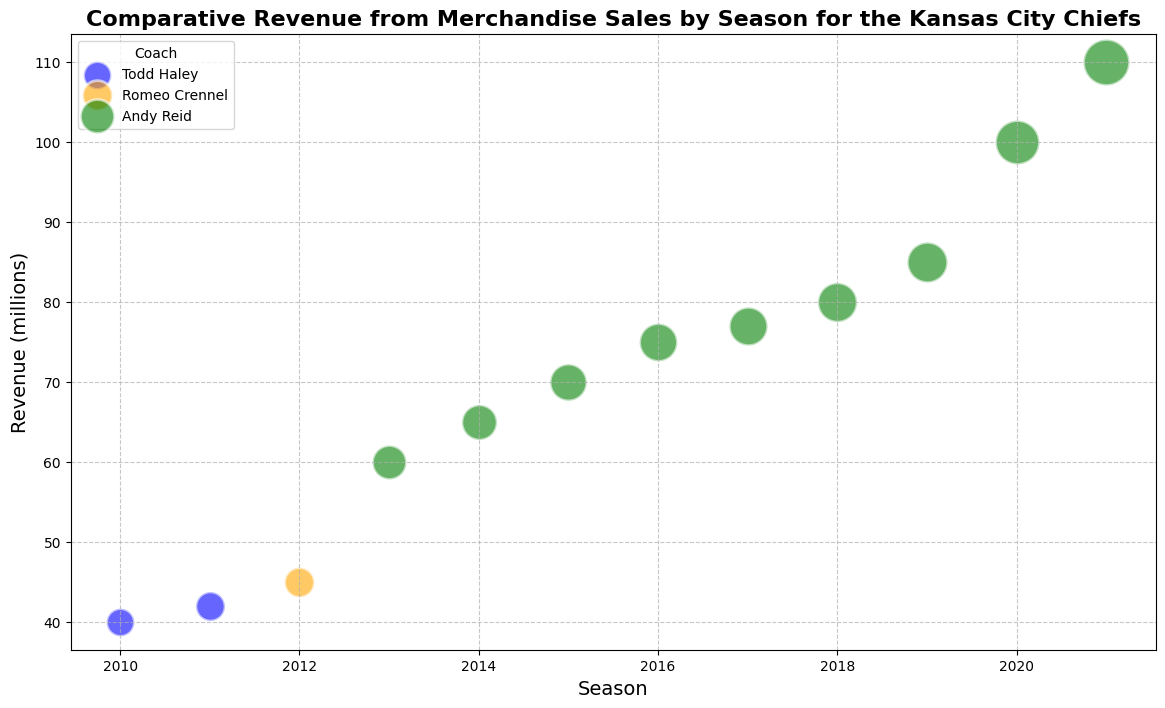Which season had the highest revenue? By looking at the vertical axis (revenue) and identifying the highest point on the chart, we can see the highest revenue. The highest point on the y-axis corresponds to the 2021 season with $110 million.
Answer: 2021 How did the revenue trend under coach Andy Reid's tenure? Examine the seasons where Andy Reid was the coach (2013-2021). Notice that the revenue increases each year under him.
Answer: Revenue consistently increased each year Compare the revenue in Todd Haley's first season and Andy Reid's first season. Which was higher? Look at the revenue for each coach's first season (2010 for Todd Haley and 2013 for Andy Reid). Todd Haley's first season had $40 million while Andy Reid's had $60 million.
Answer: Andy Reid's first season What is the difference in revenue between the 2015 and 2021 seasons? Find the revenue for 2015 ($70 million) and 2021 ($110 million), then subtract the smaller value from the larger one: $110 million - $70 million = $40 million.
Answer: $40 million Among Todd Haley, Romeo Crennel, and Andy Reid, whose tenure showed the smallest bubble size and in which season? Look at the bubble sizes for each coach. The smallest bubble size is 20, which corresponds to the 2010 season under Todd Haley.
Answer: Todd Haley, 2010 Which coach's tenures are represented by which colors in the chart? Identify the colors in the legend and the corresponding coach names: Todd Haley is blue, Romeo Crennel is orange, and Andy Reid is green.
Answer: Todd Haley: blue, Romeo Crennel: orange, Andy Reid: green Calculate the average revenue over the seasons coached by Romeo Crennel and Andy Reid combined. Average = (Sum of Revenue) / (Number of Seasons). Romeo Crennel's revenue is $45 million and Andy Reid's revenues sum up to $527 million. The total for both is $572 million over 10 seasons, so $572 million / 10 = $57.2 million.
Answer: $57.2 million In which season under Andy Reid did the team see the largest increase in revenue compared to the previous season? Examine the increase year-over-year during Andy Reid's tenure. The largest increase is from 2019 ($85 million) to 2020 ($100 million), an increase of $15 million.
Answer: 2020 What is the total number of merchandise items sold during the 2017 season? Refer to the data for the 2017 season, which shows 1,300 thousand merchandise items sold.
Answer: 1,300 thousand What can be inferred about the relationship between bubble size and revenue across the seasons? Larger bubbles generally correspond to higher revenues, indicating a positive relationship between bubble size and revenue.
Answer: Positive relationship 